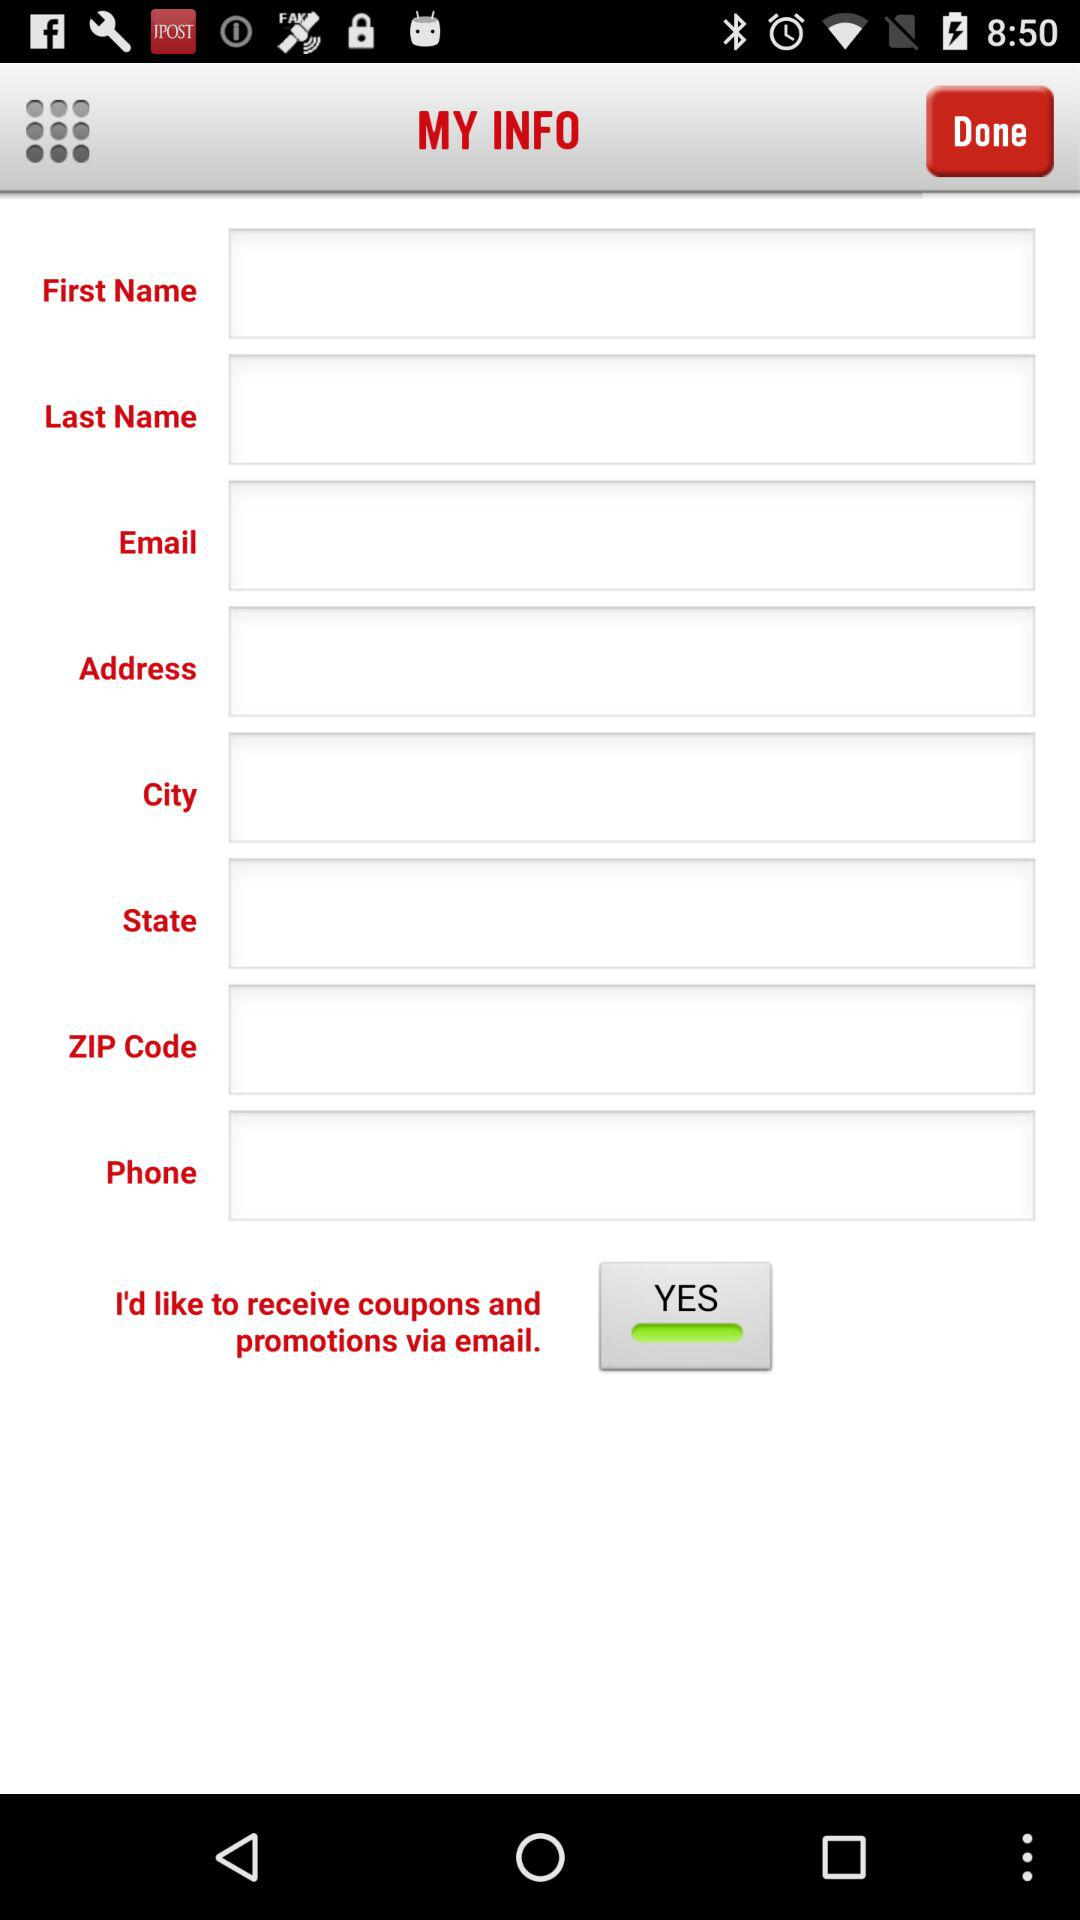What's the status of "I'd like to receive coupons and promotions via email"? The status is "YES". 